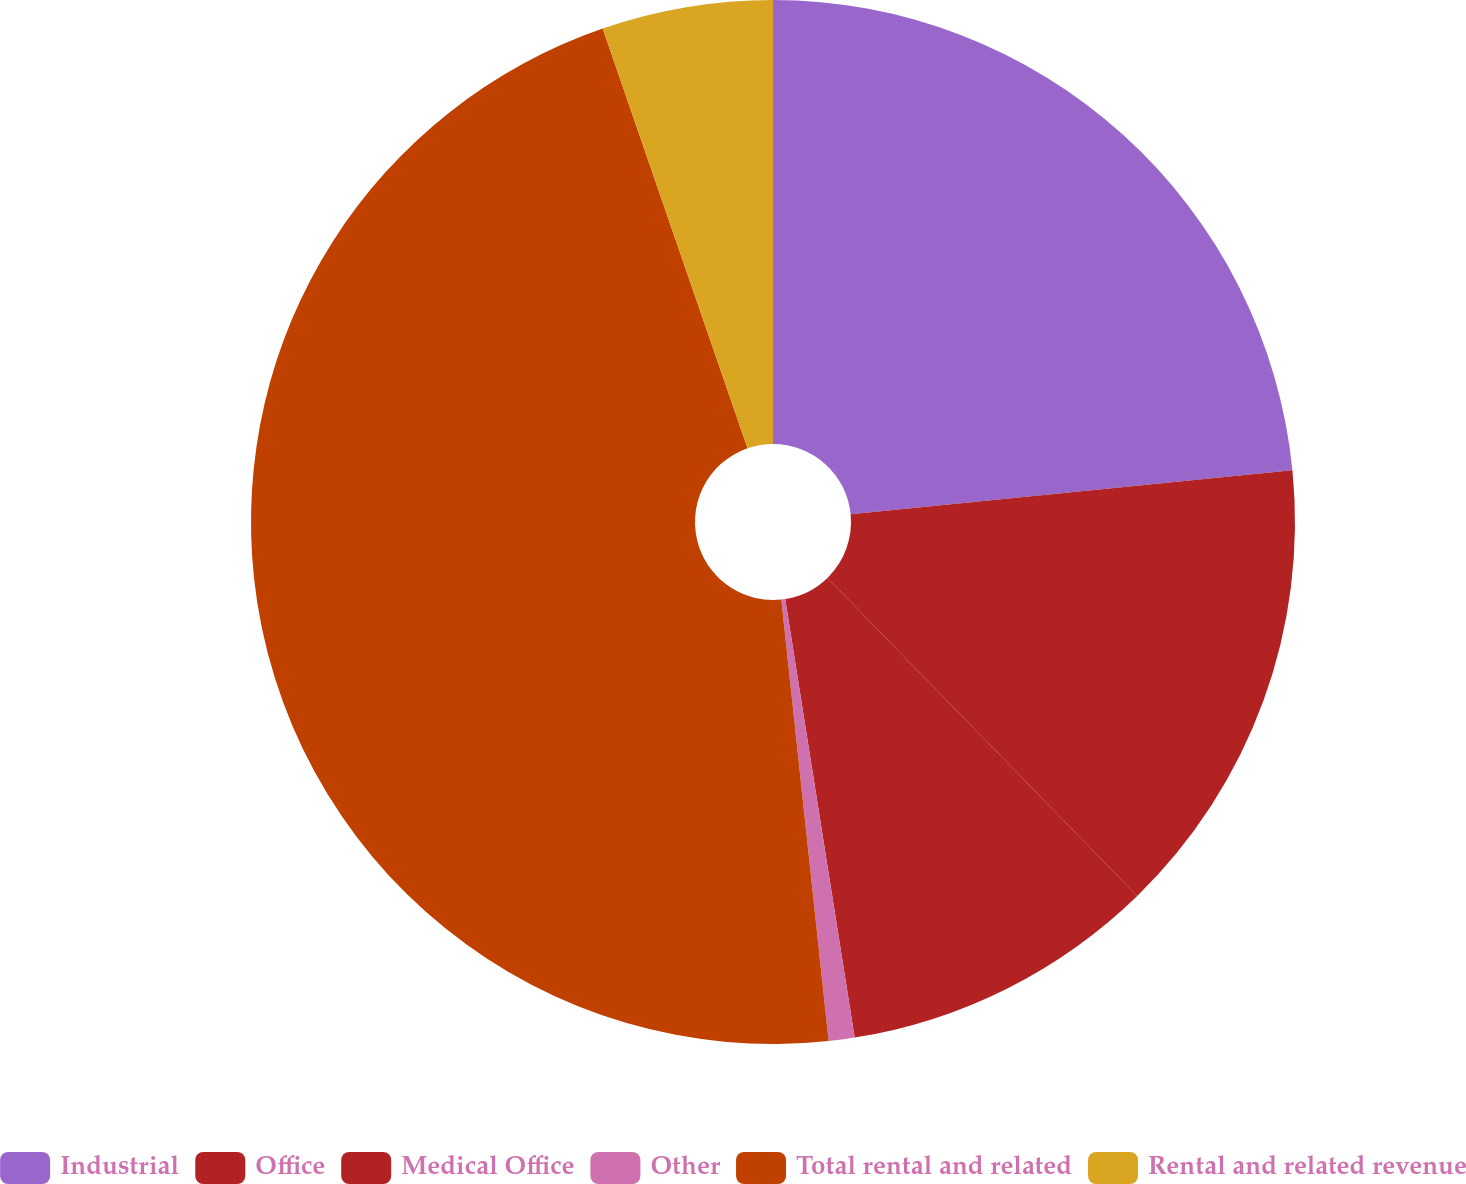Convert chart to OTSL. <chart><loc_0><loc_0><loc_500><loc_500><pie_chart><fcel>Industrial<fcel>Office<fcel>Medical Office<fcel>Other<fcel>Total rental and related<fcel>Rental and related revenue<nl><fcel>23.42%<fcel>14.29%<fcel>9.79%<fcel>0.8%<fcel>46.41%<fcel>5.29%<nl></chart> 